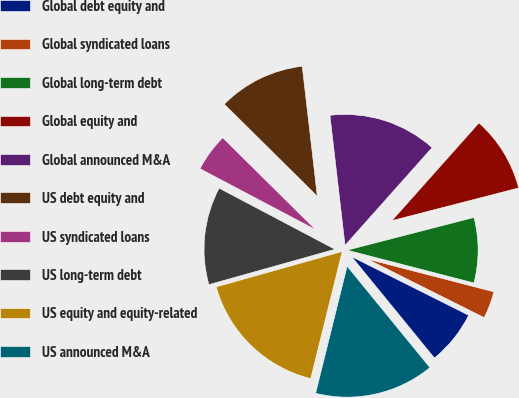<chart> <loc_0><loc_0><loc_500><loc_500><pie_chart><fcel>Global debt equity and<fcel>Global syndicated loans<fcel>Global long-term debt<fcel>Global equity and<fcel>Global announced M&A<fcel>US debt equity and<fcel>US syndicated loans<fcel>US long-term debt<fcel>US equity and equity-related<fcel>US announced M&A<nl><fcel>6.71%<fcel>3.36%<fcel>8.05%<fcel>9.4%<fcel>13.42%<fcel>10.74%<fcel>4.7%<fcel>12.08%<fcel>16.78%<fcel>14.77%<nl></chart> 